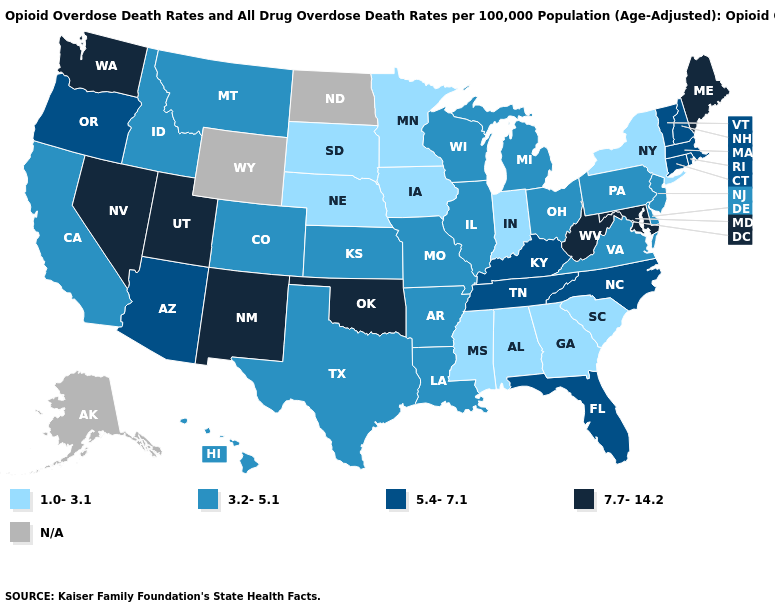Is the legend a continuous bar?
Short answer required. No. Among the states that border New Jersey , which have the highest value?
Keep it brief. Delaware, Pennsylvania. What is the value of Florida?
Write a very short answer. 5.4-7.1. What is the highest value in the USA?
Keep it brief. 7.7-14.2. Which states have the highest value in the USA?
Write a very short answer. Maine, Maryland, Nevada, New Mexico, Oklahoma, Utah, Washington, West Virginia. What is the value of California?
Short answer required. 3.2-5.1. Which states have the lowest value in the Northeast?
Be succinct. New York. What is the highest value in the Northeast ?
Be succinct. 7.7-14.2. Which states have the lowest value in the USA?
Short answer required. Alabama, Georgia, Indiana, Iowa, Minnesota, Mississippi, Nebraska, New York, South Carolina, South Dakota. What is the value of West Virginia?
Short answer required. 7.7-14.2. Among the states that border North Carolina , does Georgia have the highest value?
Give a very brief answer. No. What is the lowest value in the USA?
Quick response, please. 1.0-3.1. Name the states that have a value in the range 3.2-5.1?
Concise answer only. Arkansas, California, Colorado, Delaware, Hawaii, Idaho, Illinois, Kansas, Louisiana, Michigan, Missouri, Montana, New Jersey, Ohio, Pennsylvania, Texas, Virginia, Wisconsin. Name the states that have a value in the range 5.4-7.1?
Answer briefly. Arizona, Connecticut, Florida, Kentucky, Massachusetts, New Hampshire, North Carolina, Oregon, Rhode Island, Tennessee, Vermont. Name the states that have a value in the range 3.2-5.1?
Keep it brief. Arkansas, California, Colorado, Delaware, Hawaii, Idaho, Illinois, Kansas, Louisiana, Michigan, Missouri, Montana, New Jersey, Ohio, Pennsylvania, Texas, Virginia, Wisconsin. 